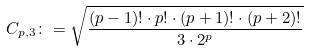<formula> <loc_0><loc_0><loc_500><loc_500>C _ { p , 3 } \colon = \sqrt { \frac { ( p - 1 ) ! \cdot p ! \cdot ( p + 1 ) ! \cdot ( p + 2 ) ! } { 3 \cdot 2 ^ { p } } }</formula> 